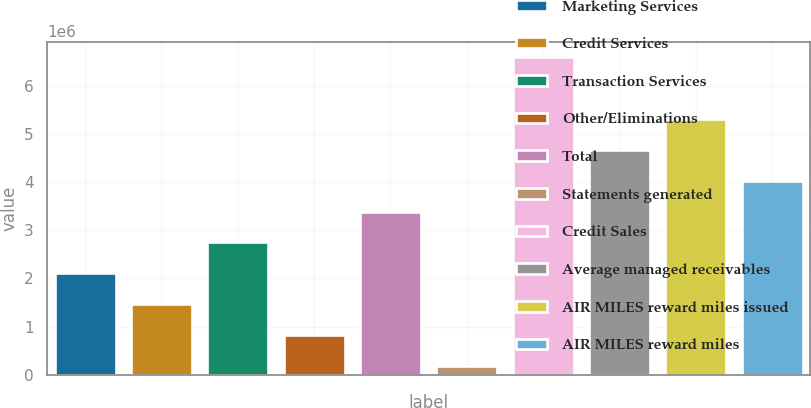Convert chart to OTSL. <chart><loc_0><loc_0><loc_500><loc_500><bar_chart><fcel>Marketing Services<fcel>Credit Services<fcel>Transaction Services<fcel>Other/Eliminations<fcel>Total<fcel>Statements generated<fcel>Credit Sales<fcel>Average managed receivables<fcel>AIR MILES reward miles issued<fcel>AIR MILES reward miles<nl><fcel>2.10848e+06<fcel>1.46929e+06<fcel>2.74767e+06<fcel>830099<fcel>3.38686e+06<fcel>190910<fcel>6.5828e+06<fcel>4.66523e+06<fcel>5.30442e+06<fcel>4.02604e+06<nl></chart> 